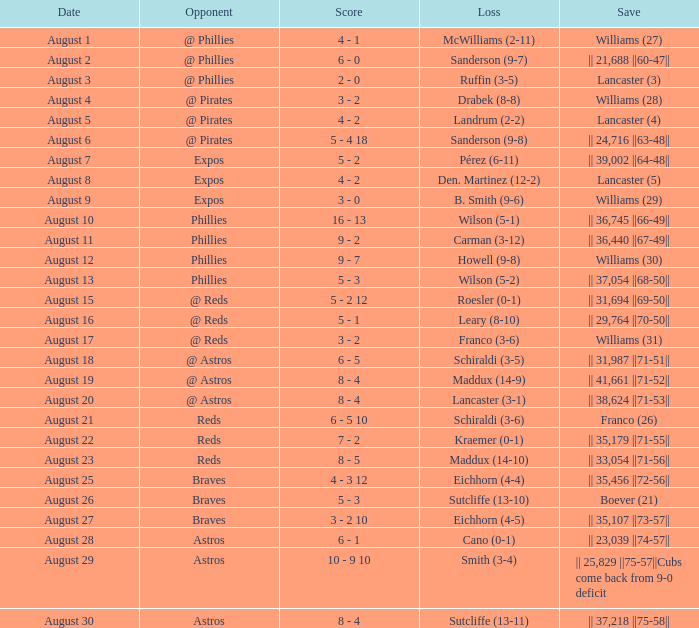Who was the rival defeated by sanderson with a 9-8 score? @ Pirates. 